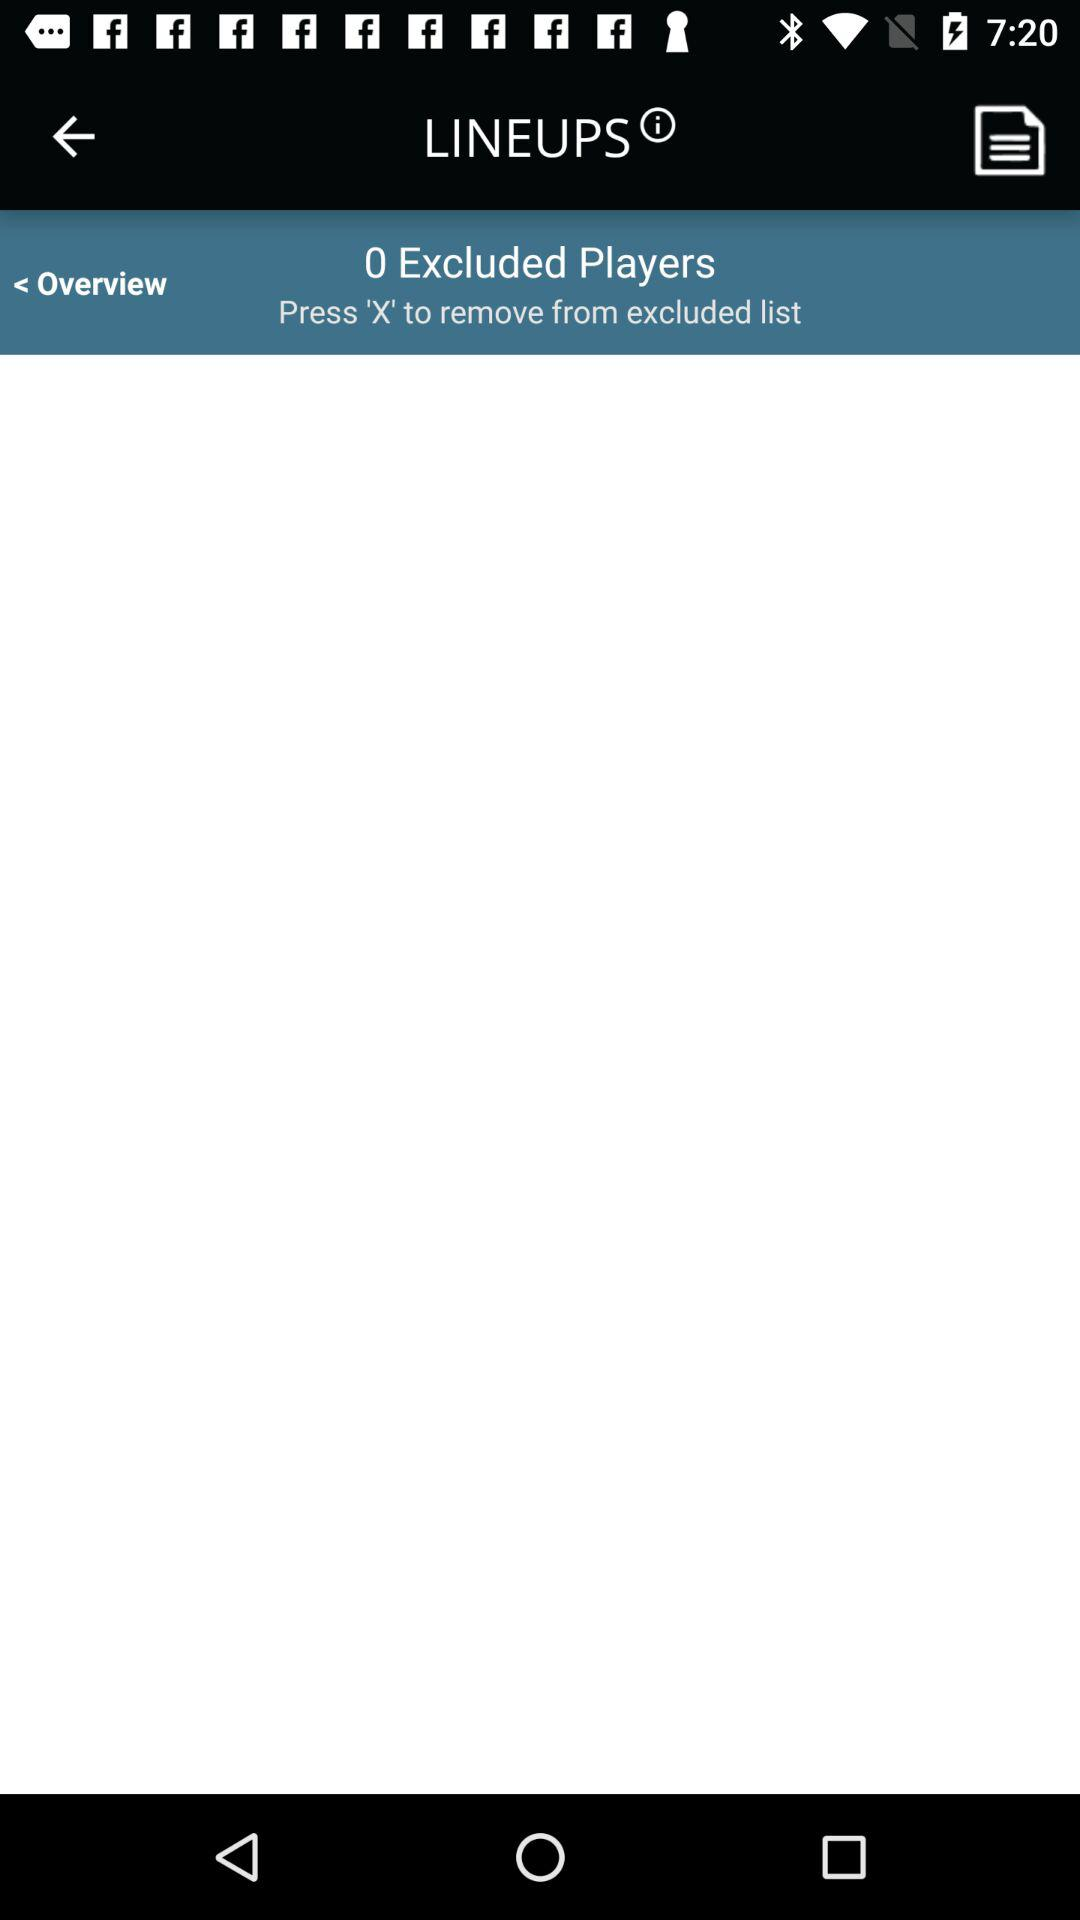How many players are excluded from the lineup?
Answer the question using a single word or phrase. 0 